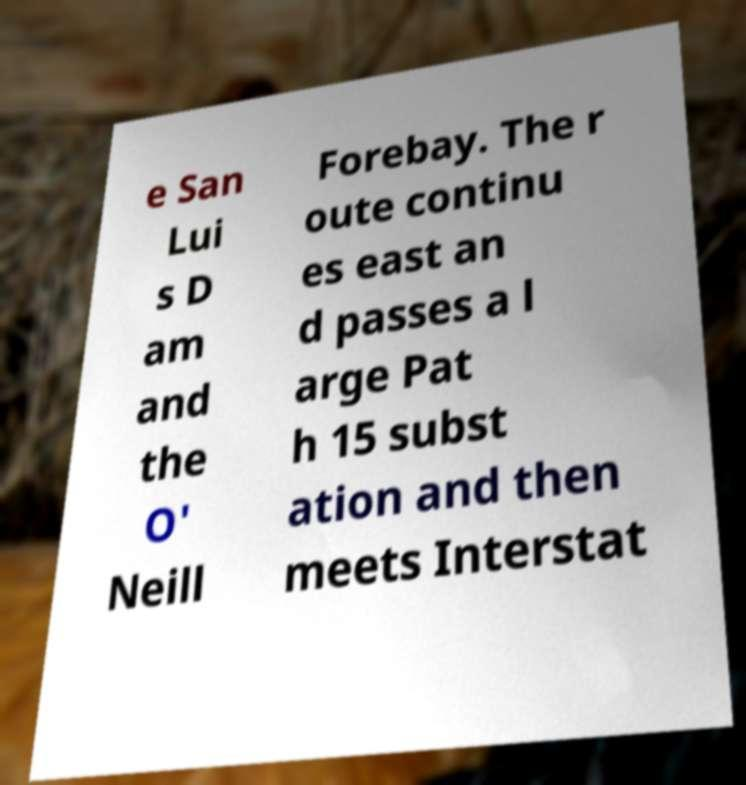Can you accurately transcribe the text from the provided image for me? e San Lui s D am and the O' Neill Forebay. The r oute continu es east an d passes a l arge Pat h 15 subst ation and then meets Interstat 